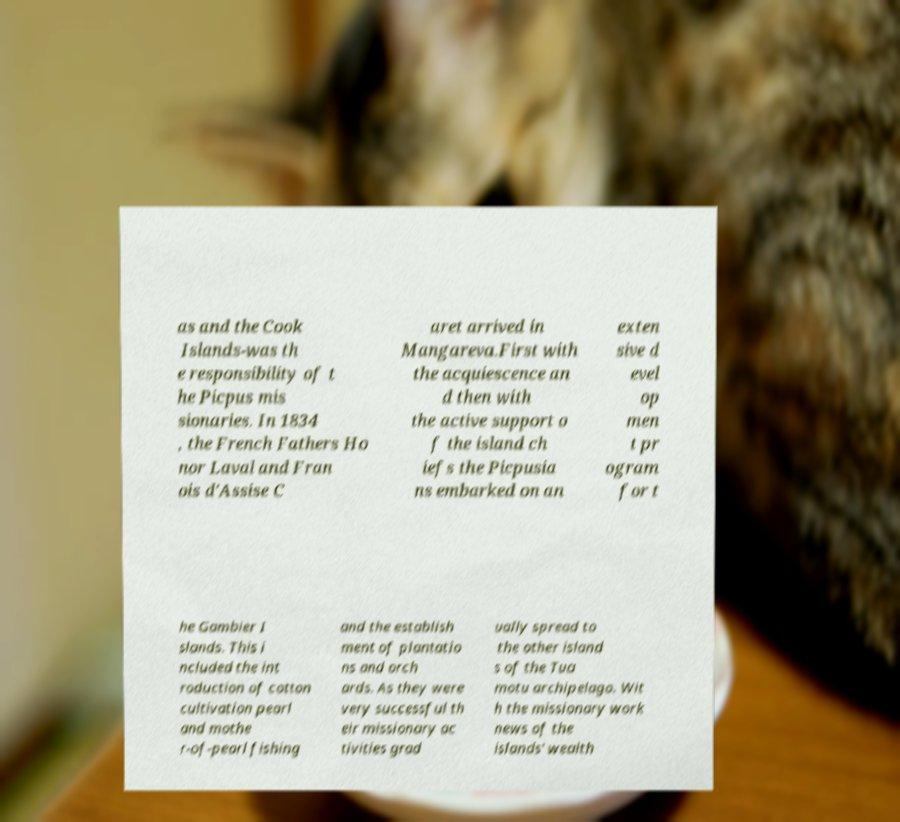Please identify and transcribe the text found in this image. as and the Cook Islands-was th e responsibility of t he Picpus mis sionaries. In 1834 , the French Fathers Ho nor Laval and Fran ois d'Assise C aret arrived in Mangareva.First with the acquiescence an d then with the active support o f the island ch iefs the Picpusia ns embarked on an exten sive d evel op men t pr ogram for t he Gambier I slands. This i ncluded the int roduction of cotton cultivation pearl and mothe r-of-pearl fishing and the establish ment of plantatio ns and orch ards. As they were very successful th eir missionary ac tivities grad ually spread to the other island s of the Tua motu archipelago. Wit h the missionary work news of the islands' wealth 